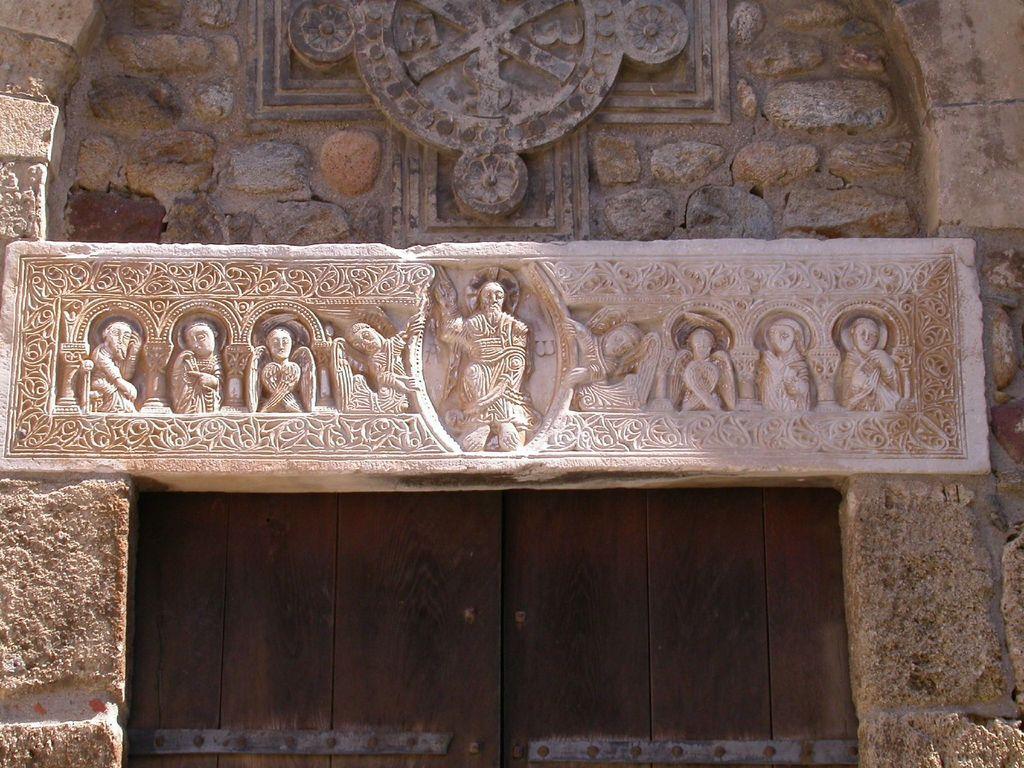Can you describe this image briefly? In this image I can see an arch of the building and the arch is in cream color, background I can see the door in brown color. 